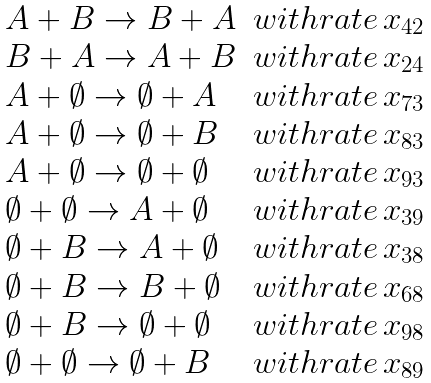<formula> <loc_0><loc_0><loc_500><loc_500>\begin{array} { l l l } A + B \rightarrow B + A & w i t h r a t e \, x _ { 4 2 } \\ B + A \rightarrow A + B & w i t h r a t e \, x _ { 2 4 } \\ A + \emptyset \rightarrow \emptyset + A & w i t h r a t e \, x _ { 7 3 } \\ A + \emptyset \rightarrow \emptyset + B & w i t h r a t e \, x _ { 8 3 } \\ A + \emptyset \rightarrow \emptyset + \emptyset & w i t h r a t e \, x _ { 9 3 } \\ \emptyset + \emptyset \rightarrow A + \emptyset & w i t h r a t e \, x _ { 3 9 } \\ \emptyset + B \rightarrow A + \emptyset & w i t h r a t e \, x _ { 3 8 } \\ \emptyset + B \rightarrow B + \emptyset & w i t h r a t e \, x _ { 6 8 } \\ \emptyset + B \rightarrow \emptyset + \emptyset & w i t h r a t e \, x _ { 9 8 } \\ \emptyset + \emptyset \rightarrow \emptyset + B & w i t h r a t e \, x _ { 8 9 } \\ \end{array}</formula> 